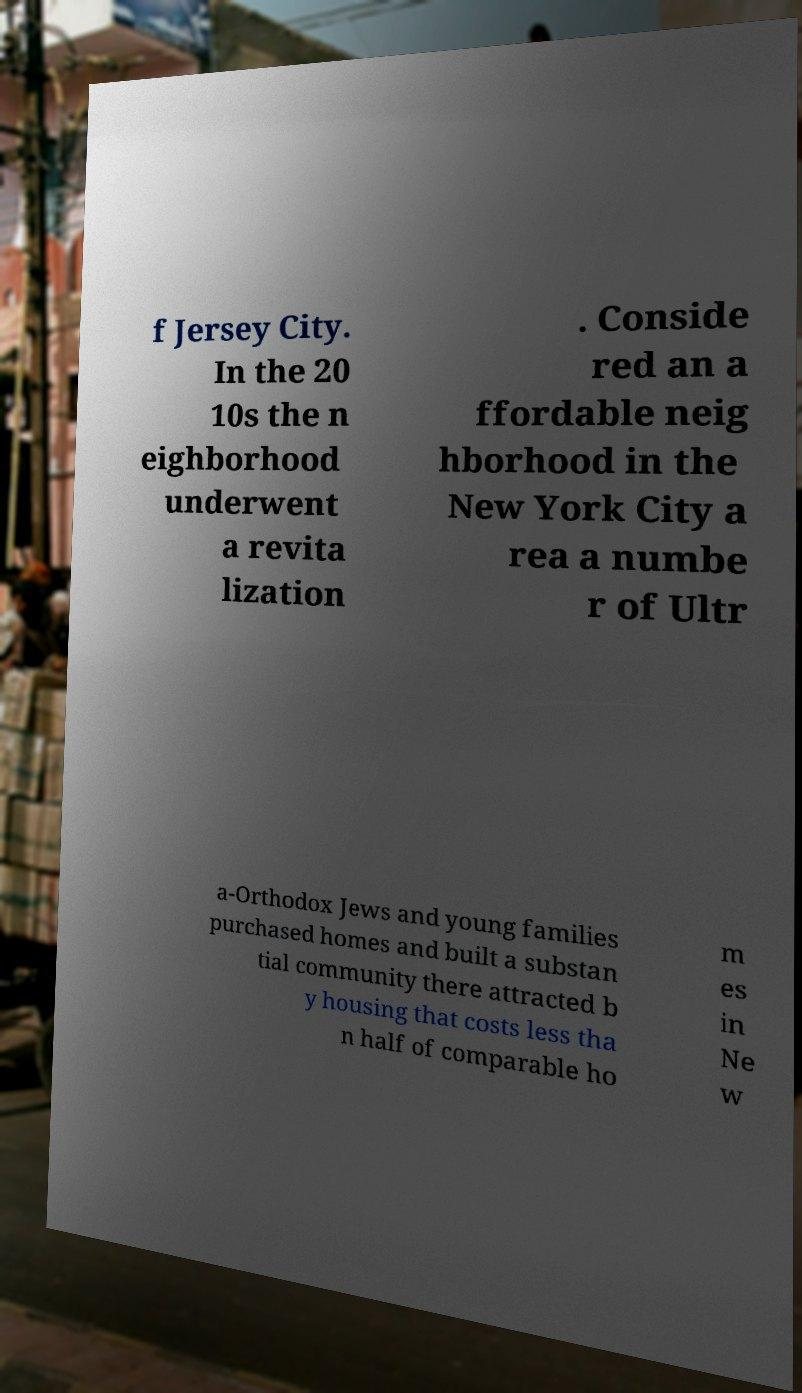There's text embedded in this image that I need extracted. Can you transcribe it verbatim? f Jersey City. In the 20 10s the n eighborhood underwent a revita lization . Conside red an a ffordable neig hborhood in the New York City a rea a numbe r of Ultr a-Orthodox Jews and young families purchased homes and built a substan tial community there attracted b y housing that costs less tha n half of comparable ho m es in Ne w 